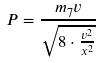<formula> <loc_0><loc_0><loc_500><loc_500>P = \frac { m _ { 7 } v } { \sqrt { 8 \cdot \frac { v ^ { 2 } } { x ^ { 2 } } } }</formula> 